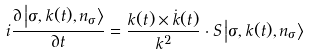Convert formula to latex. <formula><loc_0><loc_0><loc_500><loc_500>i \frac { \partial \left | \sigma , { k } ( t ) , n _ { \sigma } \right \rangle } { \partial t } = \frac { { k } ( t ) \times \dot { k } ( t ) } { k ^ { 2 } } \cdot { S } \left | \sigma , { k } ( t ) , n _ { \sigma } \right \rangle</formula> 